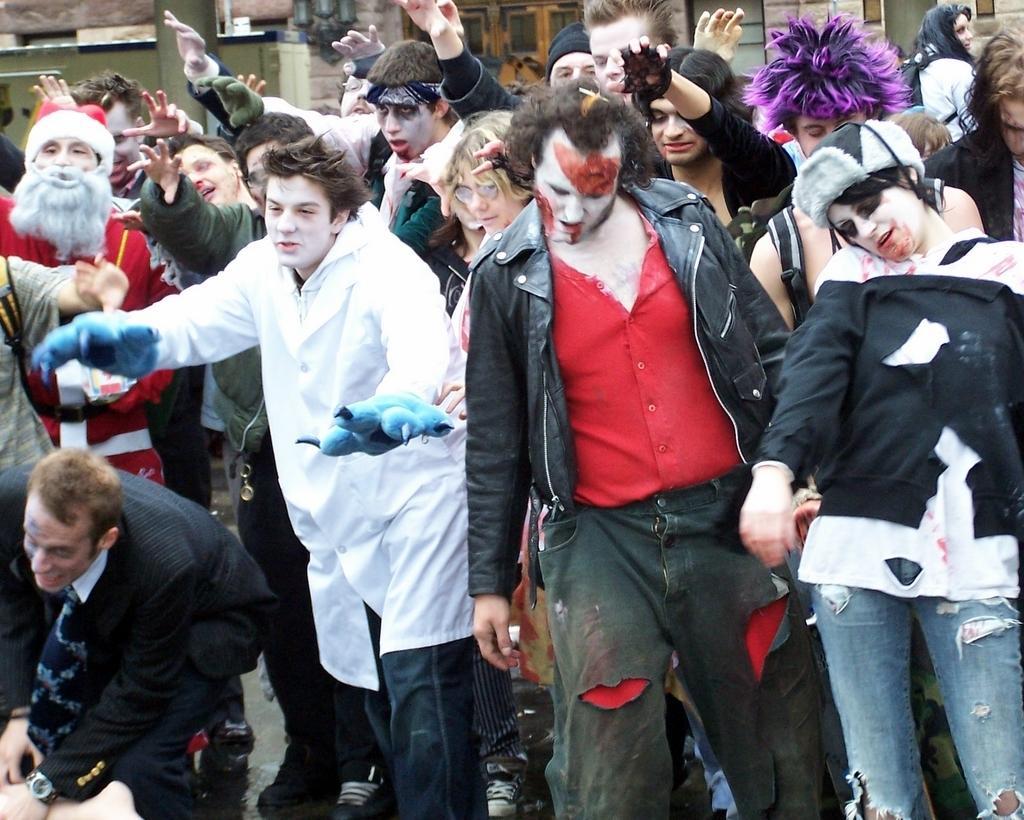Could you give a brief overview of what you see in this image? In this image I can see the group of people standing and wearing the different color dress. In the back I can see the building which is in green color. I can also see few people with hats. 